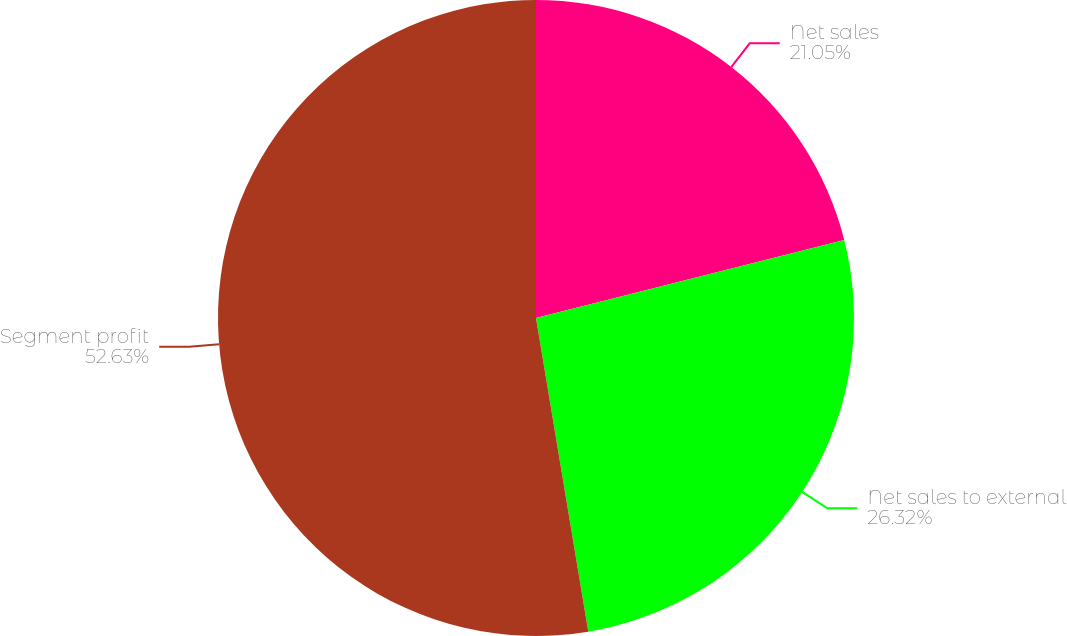Convert chart. <chart><loc_0><loc_0><loc_500><loc_500><pie_chart><fcel>Net sales<fcel>Net sales to external<fcel>Segment profit<nl><fcel>21.05%<fcel>26.32%<fcel>52.63%<nl></chart> 